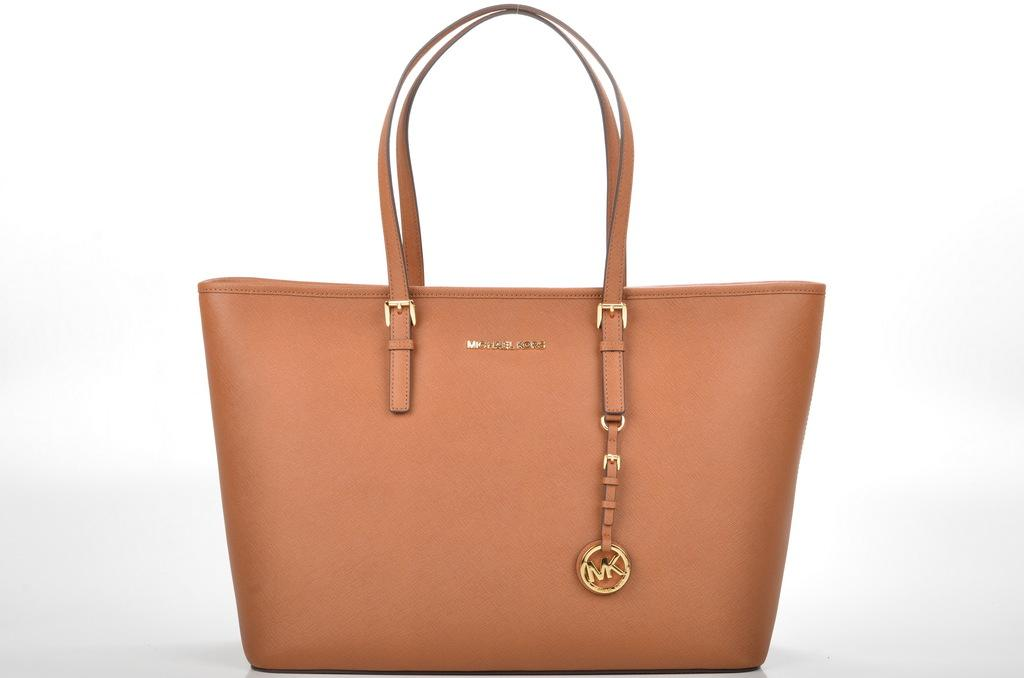What object can be seen in the image? There is a handbag in the image. What is the color of the handbag? The handbag is brown in color. Where is the camp located in the image? There is no camp present in the image; it only features a brown handbag. What type of toothpaste is being used in the image? There is no toothpaste present in the image; it only features a brown handbag. 